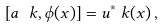<formula> <loc_0><loc_0><loc_500><loc_500>\left [ a _ { \ } k , \phi ( x ) \right ] = u ^ { * } _ { \ } k ( x ) \, ,</formula> 